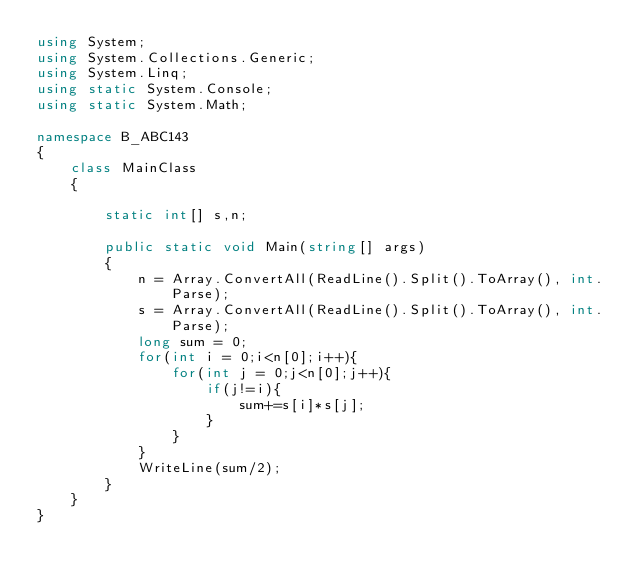<code> <loc_0><loc_0><loc_500><loc_500><_C#_>using System;
using System.Collections.Generic;
using System.Linq;
using static System.Console;
using static System.Math;

namespace B_ABC143
{
    class MainClass
    {

        static int[] s,n;

        public static void Main(string[] args)
        {
            n = Array.ConvertAll(ReadLine().Split().ToArray(), int.Parse);
            s = Array.ConvertAll(ReadLine().Split().ToArray(), int.Parse);
            long sum = 0;
            for(int i = 0;i<n[0];i++){
                for(int j = 0;j<n[0];j++){
                    if(j!=i){
                        sum+=s[i]*s[j];
                    }
                }
            }
            WriteLine(sum/2);
        }
    }
}
</code> 